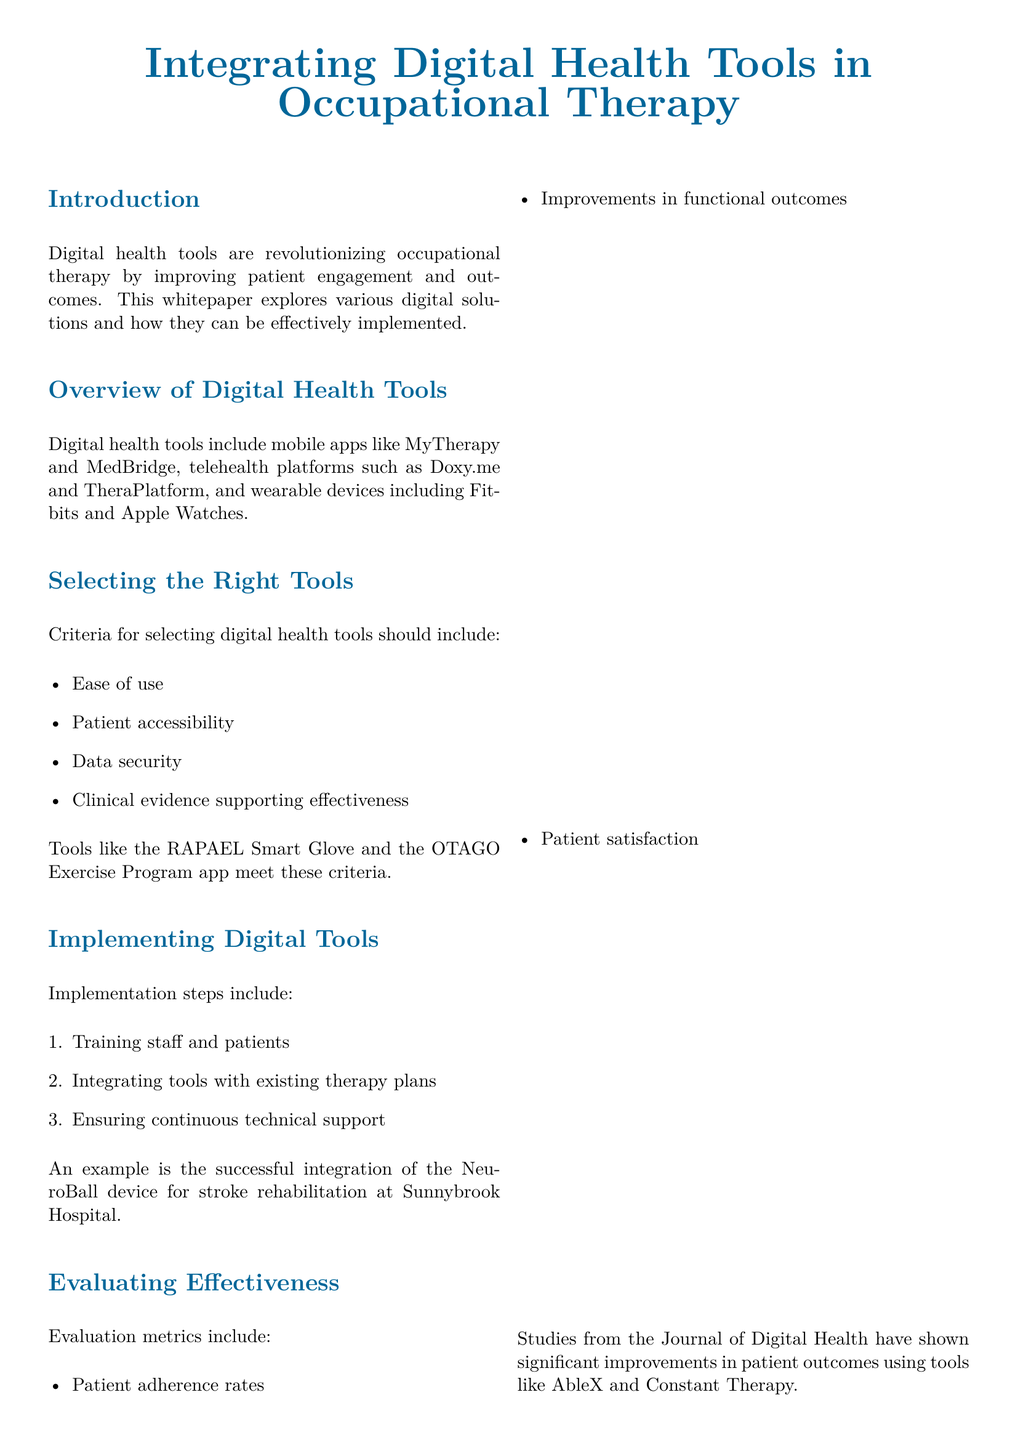What are digital health tools in occupational therapy? Digital health tools include mobile apps, telehealth platforms, and wearable devices that improve patient engagement and outcomes in occupational therapy.
Answer: Mobile apps, telehealth platforms, and wearable devices What is one example of a telehealth platform mentioned? The document lists specific telehealth platforms, one of which is Doxy.me.
Answer: Doxy.me What criteria should be used in selecting digital health tools? The document provides a list of criteria for tool selection, including ease of use and clinical evidence supporting effectiveness.
Answer: Ease of use, patient accessibility, data security, clinical evidence How many steps are suggested for implementing digital tools? The implementation section details a specific number of steps to follow when integrating digital tools into therapy plans.
Answer: Three What is one of the evaluation metrics mentioned? The document discusses several evaluation metrics to assess effectiveness, one being patient adherence rates.
Answer: Patient adherence rates Which device was successfully integrated for stroke rehabilitation? The document gives an example of a specific device used in a successful case at Sunnybrook Hospital for rehabilitation.
Answer: NeuroBall What is a key benefit of digital health tools listed in the document? The document includes a section highlighting key benefits, with one being enhanced patient engagement.
Answer: Enhanced patient engagement What type of document is this? This document describes itself at the end, providing context about its content and purpose.
Answer: Whitepaper 